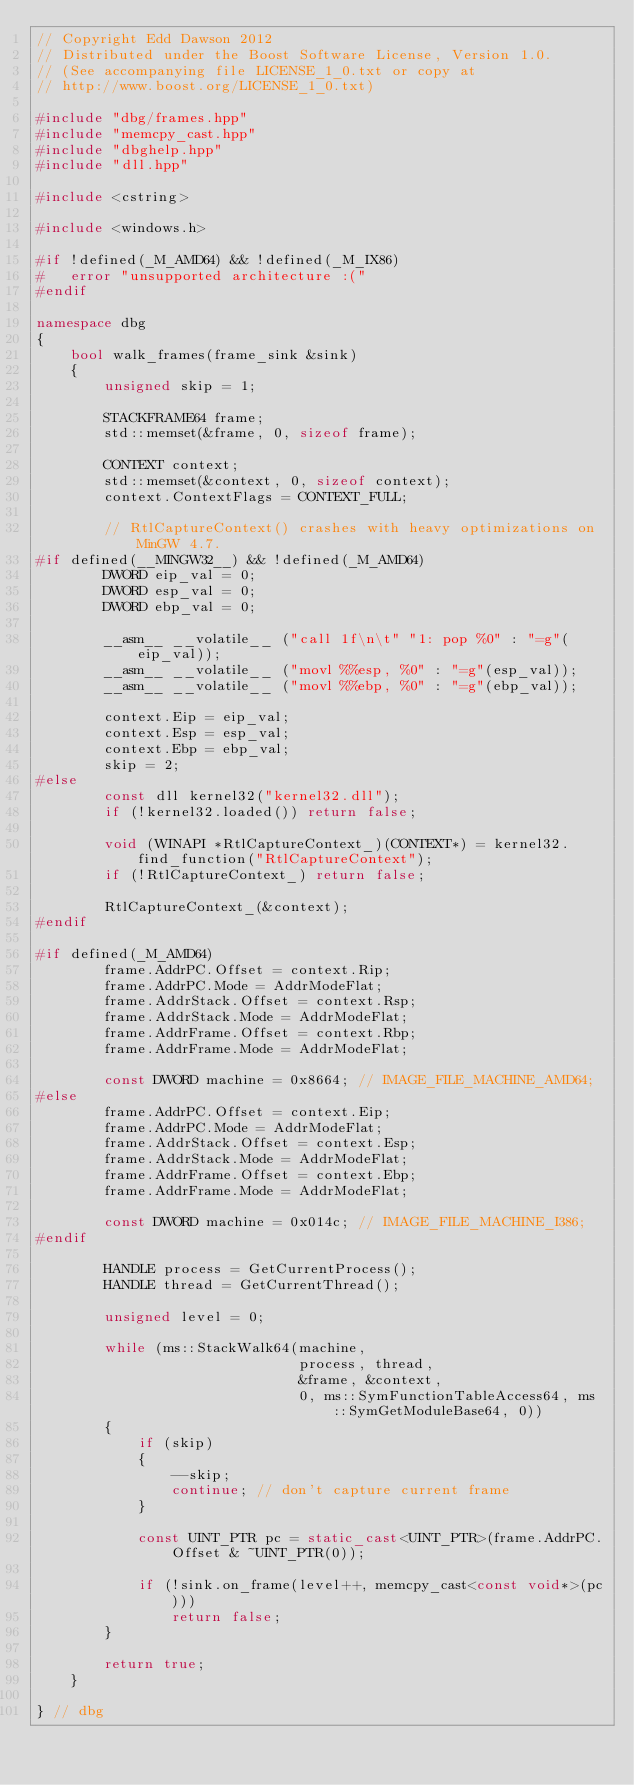Convert code to text. <code><loc_0><loc_0><loc_500><loc_500><_C++_>// Copyright Edd Dawson 2012
// Distributed under the Boost Software License, Version 1.0.
// (See accompanying file LICENSE_1_0.txt or copy at
// http://www.boost.org/LICENSE_1_0.txt)

#include "dbg/frames.hpp"
#include "memcpy_cast.hpp"
#include "dbghelp.hpp"
#include "dll.hpp"

#include <cstring>

#include <windows.h>

#if !defined(_M_AMD64) && !defined(_M_IX86)
#   error "unsupported architecture :("
#endif

namespace dbg 
{
    bool walk_frames(frame_sink &sink)
    {
        unsigned skip = 1;

        STACKFRAME64 frame;
        std::memset(&frame, 0, sizeof frame);

        CONTEXT context;
        std::memset(&context, 0, sizeof context);
        context.ContextFlags = CONTEXT_FULL;

        // RtlCaptureContext() crashes with heavy optimizations on MinGW 4.7.
#if defined(__MINGW32__) && !defined(_M_AMD64)
        DWORD eip_val = 0;
        DWORD esp_val = 0;
        DWORD ebp_val = 0;

        __asm__ __volatile__ ("call 1f\n\t" "1: pop %0" : "=g"(eip_val));
        __asm__ __volatile__ ("movl %%esp, %0" : "=g"(esp_val));
        __asm__ __volatile__ ("movl %%ebp, %0" : "=g"(ebp_val));

        context.Eip = eip_val;
        context.Esp = esp_val;
        context.Ebp = ebp_val;
        skip = 2;
#else
        const dll kernel32("kernel32.dll");
        if (!kernel32.loaded()) return false;

        void (WINAPI *RtlCaptureContext_)(CONTEXT*) = kernel32.find_function("RtlCaptureContext");
        if (!RtlCaptureContext_) return false;

        RtlCaptureContext_(&context);
#endif

#if defined(_M_AMD64)
        frame.AddrPC.Offset = context.Rip;
        frame.AddrPC.Mode = AddrModeFlat;
        frame.AddrStack.Offset = context.Rsp;
        frame.AddrStack.Mode = AddrModeFlat;
        frame.AddrFrame.Offset = context.Rbp;
        frame.AddrFrame.Mode = AddrModeFlat;

        const DWORD machine = 0x8664; // IMAGE_FILE_MACHINE_AMD64;
#else
        frame.AddrPC.Offset = context.Eip;
        frame.AddrPC.Mode = AddrModeFlat;
        frame.AddrStack.Offset = context.Esp;
        frame.AddrStack.Mode = AddrModeFlat;
        frame.AddrFrame.Offset = context.Ebp;
        frame.AddrFrame.Mode = AddrModeFlat;

        const DWORD machine = 0x014c; // IMAGE_FILE_MACHINE_I386;
#endif

        HANDLE process = GetCurrentProcess();
        HANDLE thread = GetCurrentThread();

        unsigned level = 0;

        while (ms::StackWalk64(machine, 
                               process, thread, 
                               &frame, &context, 
                               0, ms::SymFunctionTableAccess64, ms::SymGetModuleBase64, 0))
        {
            if (skip)
            {
                --skip;
                continue; // don't capture current frame
            }

            const UINT_PTR pc = static_cast<UINT_PTR>(frame.AddrPC.Offset & ~UINT_PTR(0));

            if (!sink.on_frame(level++, memcpy_cast<const void*>(pc))) 
                return false;
        }

        return true;
    }

} // dbg
</code> 